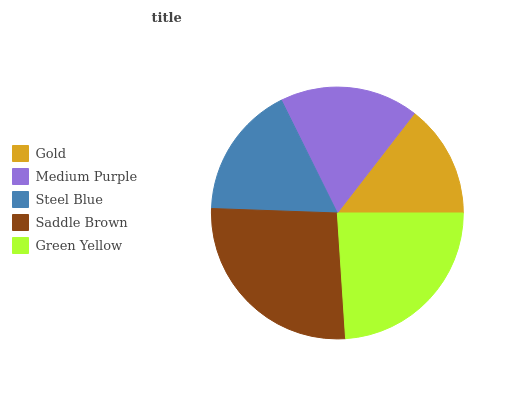Is Gold the minimum?
Answer yes or no. Yes. Is Saddle Brown the maximum?
Answer yes or no. Yes. Is Medium Purple the minimum?
Answer yes or no. No. Is Medium Purple the maximum?
Answer yes or no. No. Is Medium Purple greater than Gold?
Answer yes or no. Yes. Is Gold less than Medium Purple?
Answer yes or no. Yes. Is Gold greater than Medium Purple?
Answer yes or no. No. Is Medium Purple less than Gold?
Answer yes or no. No. Is Medium Purple the high median?
Answer yes or no. Yes. Is Medium Purple the low median?
Answer yes or no. Yes. Is Saddle Brown the high median?
Answer yes or no. No. Is Green Yellow the low median?
Answer yes or no. No. 